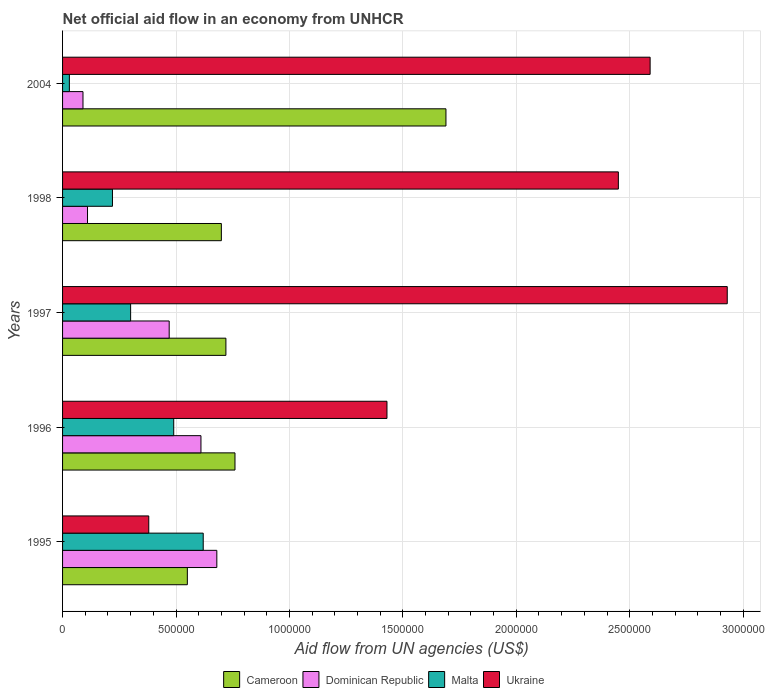How many different coloured bars are there?
Ensure brevity in your answer.  4. How many groups of bars are there?
Give a very brief answer. 5. Are the number of bars on each tick of the Y-axis equal?
Ensure brevity in your answer.  Yes. What is the net official aid flow in Malta in 1998?
Your answer should be very brief. 2.20e+05. Across all years, what is the maximum net official aid flow in Cameroon?
Give a very brief answer. 1.69e+06. In which year was the net official aid flow in Malta maximum?
Offer a terse response. 1995. In which year was the net official aid flow in Ukraine minimum?
Give a very brief answer. 1995. What is the total net official aid flow in Malta in the graph?
Give a very brief answer. 1.66e+06. What is the difference between the net official aid flow in Ukraine in 2004 and the net official aid flow in Dominican Republic in 1997?
Offer a terse response. 2.12e+06. What is the average net official aid flow in Dominican Republic per year?
Give a very brief answer. 3.92e+05. In the year 1996, what is the difference between the net official aid flow in Malta and net official aid flow in Ukraine?
Give a very brief answer. -9.40e+05. In how many years, is the net official aid flow in Cameroon greater than 2100000 US$?
Offer a terse response. 0. What is the ratio of the net official aid flow in Cameroon in 1995 to that in 1998?
Keep it short and to the point. 0.79. Is the net official aid flow in Malta in 1997 less than that in 1998?
Ensure brevity in your answer.  No. What is the difference between the highest and the lowest net official aid flow in Dominican Republic?
Give a very brief answer. 5.90e+05. In how many years, is the net official aid flow in Dominican Republic greater than the average net official aid flow in Dominican Republic taken over all years?
Your answer should be very brief. 3. Is the sum of the net official aid flow in Ukraine in 1995 and 1996 greater than the maximum net official aid flow in Malta across all years?
Keep it short and to the point. Yes. Is it the case that in every year, the sum of the net official aid flow in Malta and net official aid flow in Cameroon is greater than the sum of net official aid flow in Dominican Republic and net official aid flow in Ukraine?
Your response must be concise. No. What does the 2nd bar from the top in 1995 represents?
Offer a very short reply. Malta. What does the 2nd bar from the bottom in 1997 represents?
Offer a terse response. Dominican Republic. Is it the case that in every year, the sum of the net official aid flow in Malta and net official aid flow in Dominican Republic is greater than the net official aid flow in Cameroon?
Provide a short and direct response. No. Are all the bars in the graph horizontal?
Ensure brevity in your answer.  Yes. How many years are there in the graph?
Your answer should be compact. 5. Are the values on the major ticks of X-axis written in scientific E-notation?
Your answer should be very brief. No. Does the graph contain grids?
Provide a short and direct response. Yes. Where does the legend appear in the graph?
Provide a succinct answer. Bottom center. What is the title of the graph?
Ensure brevity in your answer.  Net official aid flow in an economy from UNHCR. What is the label or title of the X-axis?
Your response must be concise. Aid flow from UN agencies (US$). What is the Aid flow from UN agencies (US$) in Cameroon in 1995?
Keep it short and to the point. 5.50e+05. What is the Aid flow from UN agencies (US$) in Dominican Republic in 1995?
Give a very brief answer. 6.80e+05. What is the Aid flow from UN agencies (US$) in Malta in 1995?
Your answer should be compact. 6.20e+05. What is the Aid flow from UN agencies (US$) of Ukraine in 1995?
Give a very brief answer. 3.80e+05. What is the Aid flow from UN agencies (US$) of Cameroon in 1996?
Give a very brief answer. 7.60e+05. What is the Aid flow from UN agencies (US$) in Dominican Republic in 1996?
Offer a very short reply. 6.10e+05. What is the Aid flow from UN agencies (US$) in Ukraine in 1996?
Make the answer very short. 1.43e+06. What is the Aid flow from UN agencies (US$) of Cameroon in 1997?
Provide a succinct answer. 7.20e+05. What is the Aid flow from UN agencies (US$) in Dominican Republic in 1997?
Offer a very short reply. 4.70e+05. What is the Aid flow from UN agencies (US$) in Malta in 1997?
Make the answer very short. 3.00e+05. What is the Aid flow from UN agencies (US$) in Ukraine in 1997?
Your answer should be very brief. 2.93e+06. What is the Aid flow from UN agencies (US$) of Ukraine in 1998?
Offer a very short reply. 2.45e+06. What is the Aid flow from UN agencies (US$) of Cameroon in 2004?
Provide a short and direct response. 1.69e+06. What is the Aid flow from UN agencies (US$) in Dominican Republic in 2004?
Keep it short and to the point. 9.00e+04. What is the Aid flow from UN agencies (US$) in Ukraine in 2004?
Offer a terse response. 2.59e+06. Across all years, what is the maximum Aid flow from UN agencies (US$) of Cameroon?
Your response must be concise. 1.69e+06. Across all years, what is the maximum Aid flow from UN agencies (US$) of Dominican Republic?
Offer a terse response. 6.80e+05. Across all years, what is the maximum Aid flow from UN agencies (US$) in Malta?
Your response must be concise. 6.20e+05. Across all years, what is the maximum Aid flow from UN agencies (US$) in Ukraine?
Provide a succinct answer. 2.93e+06. Across all years, what is the minimum Aid flow from UN agencies (US$) of Cameroon?
Provide a short and direct response. 5.50e+05. Across all years, what is the minimum Aid flow from UN agencies (US$) of Malta?
Your response must be concise. 3.00e+04. What is the total Aid flow from UN agencies (US$) in Cameroon in the graph?
Provide a short and direct response. 4.42e+06. What is the total Aid flow from UN agencies (US$) in Dominican Republic in the graph?
Provide a succinct answer. 1.96e+06. What is the total Aid flow from UN agencies (US$) in Malta in the graph?
Your response must be concise. 1.66e+06. What is the total Aid flow from UN agencies (US$) in Ukraine in the graph?
Offer a very short reply. 9.78e+06. What is the difference between the Aid flow from UN agencies (US$) in Cameroon in 1995 and that in 1996?
Offer a very short reply. -2.10e+05. What is the difference between the Aid flow from UN agencies (US$) of Ukraine in 1995 and that in 1996?
Your response must be concise. -1.05e+06. What is the difference between the Aid flow from UN agencies (US$) in Ukraine in 1995 and that in 1997?
Provide a succinct answer. -2.55e+06. What is the difference between the Aid flow from UN agencies (US$) in Cameroon in 1995 and that in 1998?
Make the answer very short. -1.50e+05. What is the difference between the Aid flow from UN agencies (US$) of Dominican Republic in 1995 and that in 1998?
Your answer should be very brief. 5.70e+05. What is the difference between the Aid flow from UN agencies (US$) of Ukraine in 1995 and that in 1998?
Provide a short and direct response. -2.07e+06. What is the difference between the Aid flow from UN agencies (US$) of Cameroon in 1995 and that in 2004?
Keep it short and to the point. -1.14e+06. What is the difference between the Aid flow from UN agencies (US$) of Dominican Republic in 1995 and that in 2004?
Offer a terse response. 5.90e+05. What is the difference between the Aid flow from UN agencies (US$) of Malta in 1995 and that in 2004?
Ensure brevity in your answer.  5.90e+05. What is the difference between the Aid flow from UN agencies (US$) of Ukraine in 1995 and that in 2004?
Your answer should be compact. -2.21e+06. What is the difference between the Aid flow from UN agencies (US$) of Dominican Republic in 1996 and that in 1997?
Provide a succinct answer. 1.40e+05. What is the difference between the Aid flow from UN agencies (US$) in Ukraine in 1996 and that in 1997?
Offer a very short reply. -1.50e+06. What is the difference between the Aid flow from UN agencies (US$) of Malta in 1996 and that in 1998?
Keep it short and to the point. 2.70e+05. What is the difference between the Aid flow from UN agencies (US$) of Ukraine in 1996 and that in 1998?
Give a very brief answer. -1.02e+06. What is the difference between the Aid flow from UN agencies (US$) in Cameroon in 1996 and that in 2004?
Keep it short and to the point. -9.30e+05. What is the difference between the Aid flow from UN agencies (US$) in Dominican Republic in 1996 and that in 2004?
Offer a terse response. 5.20e+05. What is the difference between the Aid flow from UN agencies (US$) of Malta in 1996 and that in 2004?
Provide a succinct answer. 4.60e+05. What is the difference between the Aid flow from UN agencies (US$) in Ukraine in 1996 and that in 2004?
Ensure brevity in your answer.  -1.16e+06. What is the difference between the Aid flow from UN agencies (US$) in Cameroon in 1997 and that in 1998?
Give a very brief answer. 2.00e+04. What is the difference between the Aid flow from UN agencies (US$) in Ukraine in 1997 and that in 1998?
Give a very brief answer. 4.80e+05. What is the difference between the Aid flow from UN agencies (US$) of Cameroon in 1997 and that in 2004?
Ensure brevity in your answer.  -9.70e+05. What is the difference between the Aid flow from UN agencies (US$) in Malta in 1997 and that in 2004?
Ensure brevity in your answer.  2.70e+05. What is the difference between the Aid flow from UN agencies (US$) of Ukraine in 1997 and that in 2004?
Your response must be concise. 3.40e+05. What is the difference between the Aid flow from UN agencies (US$) of Cameroon in 1998 and that in 2004?
Your answer should be very brief. -9.90e+05. What is the difference between the Aid flow from UN agencies (US$) of Malta in 1998 and that in 2004?
Your answer should be compact. 1.90e+05. What is the difference between the Aid flow from UN agencies (US$) of Ukraine in 1998 and that in 2004?
Your answer should be very brief. -1.40e+05. What is the difference between the Aid flow from UN agencies (US$) in Cameroon in 1995 and the Aid flow from UN agencies (US$) in Ukraine in 1996?
Your answer should be compact. -8.80e+05. What is the difference between the Aid flow from UN agencies (US$) in Dominican Republic in 1995 and the Aid flow from UN agencies (US$) in Malta in 1996?
Give a very brief answer. 1.90e+05. What is the difference between the Aid flow from UN agencies (US$) in Dominican Republic in 1995 and the Aid flow from UN agencies (US$) in Ukraine in 1996?
Offer a terse response. -7.50e+05. What is the difference between the Aid flow from UN agencies (US$) of Malta in 1995 and the Aid flow from UN agencies (US$) of Ukraine in 1996?
Offer a terse response. -8.10e+05. What is the difference between the Aid flow from UN agencies (US$) of Cameroon in 1995 and the Aid flow from UN agencies (US$) of Dominican Republic in 1997?
Your response must be concise. 8.00e+04. What is the difference between the Aid flow from UN agencies (US$) in Cameroon in 1995 and the Aid flow from UN agencies (US$) in Ukraine in 1997?
Provide a succinct answer. -2.38e+06. What is the difference between the Aid flow from UN agencies (US$) in Dominican Republic in 1995 and the Aid flow from UN agencies (US$) in Malta in 1997?
Ensure brevity in your answer.  3.80e+05. What is the difference between the Aid flow from UN agencies (US$) in Dominican Republic in 1995 and the Aid flow from UN agencies (US$) in Ukraine in 1997?
Provide a succinct answer. -2.25e+06. What is the difference between the Aid flow from UN agencies (US$) of Malta in 1995 and the Aid flow from UN agencies (US$) of Ukraine in 1997?
Give a very brief answer. -2.31e+06. What is the difference between the Aid flow from UN agencies (US$) of Cameroon in 1995 and the Aid flow from UN agencies (US$) of Dominican Republic in 1998?
Your response must be concise. 4.40e+05. What is the difference between the Aid flow from UN agencies (US$) of Cameroon in 1995 and the Aid flow from UN agencies (US$) of Malta in 1998?
Give a very brief answer. 3.30e+05. What is the difference between the Aid flow from UN agencies (US$) of Cameroon in 1995 and the Aid flow from UN agencies (US$) of Ukraine in 1998?
Provide a succinct answer. -1.90e+06. What is the difference between the Aid flow from UN agencies (US$) of Dominican Republic in 1995 and the Aid flow from UN agencies (US$) of Ukraine in 1998?
Provide a short and direct response. -1.77e+06. What is the difference between the Aid flow from UN agencies (US$) in Malta in 1995 and the Aid flow from UN agencies (US$) in Ukraine in 1998?
Your answer should be compact. -1.83e+06. What is the difference between the Aid flow from UN agencies (US$) of Cameroon in 1995 and the Aid flow from UN agencies (US$) of Dominican Republic in 2004?
Keep it short and to the point. 4.60e+05. What is the difference between the Aid flow from UN agencies (US$) of Cameroon in 1995 and the Aid flow from UN agencies (US$) of Malta in 2004?
Your answer should be compact. 5.20e+05. What is the difference between the Aid flow from UN agencies (US$) in Cameroon in 1995 and the Aid flow from UN agencies (US$) in Ukraine in 2004?
Provide a short and direct response. -2.04e+06. What is the difference between the Aid flow from UN agencies (US$) of Dominican Republic in 1995 and the Aid flow from UN agencies (US$) of Malta in 2004?
Provide a short and direct response. 6.50e+05. What is the difference between the Aid flow from UN agencies (US$) of Dominican Republic in 1995 and the Aid flow from UN agencies (US$) of Ukraine in 2004?
Provide a short and direct response. -1.91e+06. What is the difference between the Aid flow from UN agencies (US$) of Malta in 1995 and the Aid flow from UN agencies (US$) of Ukraine in 2004?
Make the answer very short. -1.97e+06. What is the difference between the Aid flow from UN agencies (US$) in Cameroon in 1996 and the Aid flow from UN agencies (US$) in Malta in 1997?
Your answer should be compact. 4.60e+05. What is the difference between the Aid flow from UN agencies (US$) of Cameroon in 1996 and the Aid flow from UN agencies (US$) of Ukraine in 1997?
Your answer should be very brief. -2.17e+06. What is the difference between the Aid flow from UN agencies (US$) of Dominican Republic in 1996 and the Aid flow from UN agencies (US$) of Ukraine in 1997?
Ensure brevity in your answer.  -2.32e+06. What is the difference between the Aid flow from UN agencies (US$) in Malta in 1996 and the Aid flow from UN agencies (US$) in Ukraine in 1997?
Your response must be concise. -2.44e+06. What is the difference between the Aid flow from UN agencies (US$) in Cameroon in 1996 and the Aid flow from UN agencies (US$) in Dominican Republic in 1998?
Give a very brief answer. 6.50e+05. What is the difference between the Aid flow from UN agencies (US$) in Cameroon in 1996 and the Aid flow from UN agencies (US$) in Malta in 1998?
Your answer should be compact. 5.40e+05. What is the difference between the Aid flow from UN agencies (US$) in Cameroon in 1996 and the Aid flow from UN agencies (US$) in Ukraine in 1998?
Offer a very short reply. -1.69e+06. What is the difference between the Aid flow from UN agencies (US$) of Dominican Republic in 1996 and the Aid flow from UN agencies (US$) of Malta in 1998?
Provide a succinct answer. 3.90e+05. What is the difference between the Aid flow from UN agencies (US$) of Dominican Republic in 1996 and the Aid flow from UN agencies (US$) of Ukraine in 1998?
Your answer should be compact. -1.84e+06. What is the difference between the Aid flow from UN agencies (US$) in Malta in 1996 and the Aid flow from UN agencies (US$) in Ukraine in 1998?
Offer a very short reply. -1.96e+06. What is the difference between the Aid flow from UN agencies (US$) in Cameroon in 1996 and the Aid flow from UN agencies (US$) in Dominican Republic in 2004?
Your response must be concise. 6.70e+05. What is the difference between the Aid flow from UN agencies (US$) of Cameroon in 1996 and the Aid flow from UN agencies (US$) of Malta in 2004?
Provide a short and direct response. 7.30e+05. What is the difference between the Aid flow from UN agencies (US$) in Cameroon in 1996 and the Aid flow from UN agencies (US$) in Ukraine in 2004?
Make the answer very short. -1.83e+06. What is the difference between the Aid flow from UN agencies (US$) of Dominican Republic in 1996 and the Aid flow from UN agencies (US$) of Malta in 2004?
Offer a terse response. 5.80e+05. What is the difference between the Aid flow from UN agencies (US$) of Dominican Republic in 1996 and the Aid flow from UN agencies (US$) of Ukraine in 2004?
Provide a succinct answer. -1.98e+06. What is the difference between the Aid flow from UN agencies (US$) in Malta in 1996 and the Aid flow from UN agencies (US$) in Ukraine in 2004?
Offer a very short reply. -2.10e+06. What is the difference between the Aid flow from UN agencies (US$) in Cameroon in 1997 and the Aid flow from UN agencies (US$) in Malta in 1998?
Offer a very short reply. 5.00e+05. What is the difference between the Aid flow from UN agencies (US$) of Cameroon in 1997 and the Aid flow from UN agencies (US$) of Ukraine in 1998?
Provide a succinct answer. -1.73e+06. What is the difference between the Aid flow from UN agencies (US$) of Dominican Republic in 1997 and the Aid flow from UN agencies (US$) of Malta in 1998?
Provide a succinct answer. 2.50e+05. What is the difference between the Aid flow from UN agencies (US$) of Dominican Republic in 1997 and the Aid flow from UN agencies (US$) of Ukraine in 1998?
Your response must be concise. -1.98e+06. What is the difference between the Aid flow from UN agencies (US$) of Malta in 1997 and the Aid flow from UN agencies (US$) of Ukraine in 1998?
Offer a terse response. -2.15e+06. What is the difference between the Aid flow from UN agencies (US$) in Cameroon in 1997 and the Aid flow from UN agencies (US$) in Dominican Republic in 2004?
Your answer should be very brief. 6.30e+05. What is the difference between the Aid flow from UN agencies (US$) of Cameroon in 1997 and the Aid flow from UN agencies (US$) of Malta in 2004?
Ensure brevity in your answer.  6.90e+05. What is the difference between the Aid flow from UN agencies (US$) of Cameroon in 1997 and the Aid flow from UN agencies (US$) of Ukraine in 2004?
Provide a short and direct response. -1.87e+06. What is the difference between the Aid flow from UN agencies (US$) in Dominican Republic in 1997 and the Aid flow from UN agencies (US$) in Malta in 2004?
Provide a short and direct response. 4.40e+05. What is the difference between the Aid flow from UN agencies (US$) in Dominican Republic in 1997 and the Aid flow from UN agencies (US$) in Ukraine in 2004?
Offer a very short reply. -2.12e+06. What is the difference between the Aid flow from UN agencies (US$) in Malta in 1997 and the Aid flow from UN agencies (US$) in Ukraine in 2004?
Provide a succinct answer. -2.29e+06. What is the difference between the Aid flow from UN agencies (US$) of Cameroon in 1998 and the Aid flow from UN agencies (US$) of Malta in 2004?
Offer a very short reply. 6.70e+05. What is the difference between the Aid flow from UN agencies (US$) in Cameroon in 1998 and the Aid flow from UN agencies (US$) in Ukraine in 2004?
Provide a short and direct response. -1.89e+06. What is the difference between the Aid flow from UN agencies (US$) in Dominican Republic in 1998 and the Aid flow from UN agencies (US$) in Malta in 2004?
Make the answer very short. 8.00e+04. What is the difference between the Aid flow from UN agencies (US$) of Dominican Republic in 1998 and the Aid flow from UN agencies (US$) of Ukraine in 2004?
Your answer should be compact. -2.48e+06. What is the difference between the Aid flow from UN agencies (US$) of Malta in 1998 and the Aid flow from UN agencies (US$) of Ukraine in 2004?
Make the answer very short. -2.37e+06. What is the average Aid flow from UN agencies (US$) of Cameroon per year?
Provide a succinct answer. 8.84e+05. What is the average Aid flow from UN agencies (US$) in Dominican Republic per year?
Give a very brief answer. 3.92e+05. What is the average Aid flow from UN agencies (US$) of Malta per year?
Give a very brief answer. 3.32e+05. What is the average Aid flow from UN agencies (US$) in Ukraine per year?
Your answer should be very brief. 1.96e+06. In the year 1995, what is the difference between the Aid flow from UN agencies (US$) of Cameroon and Aid flow from UN agencies (US$) of Dominican Republic?
Give a very brief answer. -1.30e+05. In the year 1995, what is the difference between the Aid flow from UN agencies (US$) in Dominican Republic and Aid flow from UN agencies (US$) in Malta?
Your answer should be compact. 6.00e+04. In the year 1995, what is the difference between the Aid flow from UN agencies (US$) in Malta and Aid flow from UN agencies (US$) in Ukraine?
Your response must be concise. 2.40e+05. In the year 1996, what is the difference between the Aid flow from UN agencies (US$) of Cameroon and Aid flow from UN agencies (US$) of Dominican Republic?
Provide a succinct answer. 1.50e+05. In the year 1996, what is the difference between the Aid flow from UN agencies (US$) in Cameroon and Aid flow from UN agencies (US$) in Ukraine?
Offer a terse response. -6.70e+05. In the year 1996, what is the difference between the Aid flow from UN agencies (US$) of Dominican Republic and Aid flow from UN agencies (US$) of Malta?
Offer a terse response. 1.20e+05. In the year 1996, what is the difference between the Aid flow from UN agencies (US$) of Dominican Republic and Aid flow from UN agencies (US$) of Ukraine?
Ensure brevity in your answer.  -8.20e+05. In the year 1996, what is the difference between the Aid flow from UN agencies (US$) in Malta and Aid flow from UN agencies (US$) in Ukraine?
Offer a terse response. -9.40e+05. In the year 1997, what is the difference between the Aid flow from UN agencies (US$) of Cameroon and Aid flow from UN agencies (US$) of Malta?
Provide a succinct answer. 4.20e+05. In the year 1997, what is the difference between the Aid flow from UN agencies (US$) in Cameroon and Aid flow from UN agencies (US$) in Ukraine?
Ensure brevity in your answer.  -2.21e+06. In the year 1997, what is the difference between the Aid flow from UN agencies (US$) in Dominican Republic and Aid flow from UN agencies (US$) in Malta?
Keep it short and to the point. 1.70e+05. In the year 1997, what is the difference between the Aid flow from UN agencies (US$) of Dominican Republic and Aid flow from UN agencies (US$) of Ukraine?
Offer a very short reply. -2.46e+06. In the year 1997, what is the difference between the Aid flow from UN agencies (US$) in Malta and Aid flow from UN agencies (US$) in Ukraine?
Provide a short and direct response. -2.63e+06. In the year 1998, what is the difference between the Aid flow from UN agencies (US$) in Cameroon and Aid flow from UN agencies (US$) in Dominican Republic?
Provide a short and direct response. 5.90e+05. In the year 1998, what is the difference between the Aid flow from UN agencies (US$) in Cameroon and Aid flow from UN agencies (US$) in Ukraine?
Provide a short and direct response. -1.75e+06. In the year 1998, what is the difference between the Aid flow from UN agencies (US$) of Dominican Republic and Aid flow from UN agencies (US$) of Malta?
Provide a succinct answer. -1.10e+05. In the year 1998, what is the difference between the Aid flow from UN agencies (US$) in Dominican Republic and Aid flow from UN agencies (US$) in Ukraine?
Provide a succinct answer. -2.34e+06. In the year 1998, what is the difference between the Aid flow from UN agencies (US$) of Malta and Aid flow from UN agencies (US$) of Ukraine?
Provide a succinct answer. -2.23e+06. In the year 2004, what is the difference between the Aid flow from UN agencies (US$) of Cameroon and Aid flow from UN agencies (US$) of Dominican Republic?
Give a very brief answer. 1.60e+06. In the year 2004, what is the difference between the Aid flow from UN agencies (US$) in Cameroon and Aid flow from UN agencies (US$) in Malta?
Your response must be concise. 1.66e+06. In the year 2004, what is the difference between the Aid flow from UN agencies (US$) of Cameroon and Aid flow from UN agencies (US$) of Ukraine?
Make the answer very short. -9.00e+05. In the year 2004, what is the difference between the Aid flow from UN agencies (US$) in Dominican Republic and Aid flow from UN agencies (US$) in Ukraine?
Ensure brevity in your answer.  -2.50e+06. In the year 2004, what is the difference between the Aid flow from UN agencies (US$) in Malta and Aid flow from UN agencies (US$) in Ukraine?
Your answer should be compact. -2.56e+06. What is the ratio of the Aid flow from UN agencies (US$) of Cameroon in 1995 to that in 1996?
Your answer should be very brief. 0.72. What is the ratio of the Aid flow from UN agencies (US$) in Dominican Republic in 1995 to that in 1996?
Your answer should be compact. 1.11. What is the ratio of the Aid flow from UN agencies (US$) of Malta in 1995 to that in 1996?
Ensure brevity in your answer.  1.27. What is the ratio of the Aid flow from UN agencies (US$) of Ukraine in 1995 to that in 1996?
Offer a very short reply. 0.27. What is the ratio of the Aid flow from UN agencies (US$) of Cameroon in 1995 to that in 1997?
Your answer should be very brief. 0.76. What is the ratio of the Aid flow from UN agencies (US$) of Dominican Republic in 1995 to that in 1997?
Your answer should be compact. 1.45. What is the ratio of the Aid flow from UN agencies (US$) in Malta in 1995 to that in 1997?
Your response must be concise. 2.07. What is the ratio of the Aid flow from UN agencies (US$) in Ukraine in 1995 to that in 1997?
Your answer should be very brief. 0.13. What is the ratio of the Aid flow from UN agencies (US$) of Cameroon in 1995 to that in 1998?
Make the answer very short. 0.79. What is the ratio of the Aid flow from UN agencies (US$) of Dominican Republic in 1995 to that in 1998?
Make the answer very short. 6.18. What is the ratio of the Aid flow from UN agencies (US$) in Malta in 1995 to that in 1998?
Your answer should be compact. 2.82. What is the ratio of the Aid flow from UN agencies (US$) in Ukraine in 1995 to that in 1998?
Your response must be concise. 0.16. What is the ratio of the Aid flow from UN agencies (US$) in Cameroon in 1995 to that in 2004?
Your response must be concise. 0.33. What is the ratio of the Aid flow from UN agencies (US$) of Dominican Republic in 1995 to that in 2004?
Offer a terse response. 7.56. What is the ratio of the Aid flow from UN agencies (US$) in Malta in 1995 to that in 2004?
Your answer should be very brief. 20.67. What is the ratio of the Aid flow from UN agencies (US$) of Ukraine in 1995 to that in 2004?
Your response must be concise. 0.15. What is the ratio of the Aid flow from UN agencies (US$) of Cameroon in 1996 to that in 1997?
Your answer should be very brief. 1.06. What is the ratio of the Aid flow from UN agencies (US$) in Dominican Republic in 1996 to that in 1997?
Provide a short and direct response. 1.3. What is the ratio of the Aid flow from UN agencies (US$) of Malta in 1996 to that in 1997?
Offer a terse response. 1.63. What is the ratio of the Aid flow from UN agencies (US$) of Ukraine in 1996 to that in 1997?
Provide a succinct answer. 0.49. What is the ratio of the Aid flow from UN agencies (US$) of Cameroon in 1996 to that in 1998?
Your answer should be very brief. 1.09. What is the ratio of the Aid flow from UN agencies (US$) in Dominican Republic in 1996 to that in 1998?
Offer a terse response. 5.55. What is the ratio of the Aid flow from UN agencies (US$) of Malta in 1996 to that in 1998?
Your answer should be very brief. 2.23. What is the ratio of the Aid flow from UN agencies (US$) in Ukraine in 1996 to that in 1998?
Offer a very short reply. 0.58. What is the ratio of the Aid flow from UN agencies (US$) in Cameroon in 1996 to that in 2004?
Your response must be concise. 0.45. What is the ratio of the Aid flow from UN agencies (US$) of Dominican Republic in 1996 to that in 2004?
Offer a terse response. 6.78. What is the ratio of the Aid flow from UN agencies (US$) of Malta in 1996 to that in 2004?
Your answer should be compact. 16.33. What is the ratio of the Aid flow from UN agencies (US$) of Ukraine in 1996 to that in 2004?
Provide a short and direct response. 0.55. What is the ratio of the Aid flow from UN agencies (US$) of Cameroon in 1997 to that in 1998?
Ensure brevity in your answer.  1.03. What is the ratio of the Aid flow from UN agencies (US$) of Dominican Republic in 1997 to that in 1998?
Offer a very short reply. 4.27. What is the ratio of the Aid flow from UN agencies (US$) of Malta in 1997 to that in 1998?
Your answer should be compact. 1.36. What is the ratio of the Aid flow from UN agencies (US$) in Ukraine in 1997 to that in 1998?
Your answer should be compact. 1.2. What is the ratio of the Aid flow from UN agencies (US$) in Cameroon in 1997 to that in 2004?
Your answer should be very brief. 0.43. What is the ratio of the Aid flow from UN agencies (US$) of Dominican Republic in 1997 to that in 2004?
Keep it short and to the point. 5.22. What is the ratio of the Aid flow from UN agencies (US$) in Ukraine in 1997 to that in 2004?
Keep it short and to the point. 1.13. What is the ratio of the Aid flow from UN agencies (US$) of Cameroon in 1998 to that in 2004?
Your answer should be very brief. 0.41. What is the ratio of the Aid flow from UN agencies (US$) of Dominican Republic in 1998 to that in 2004?
Provide a short and direct response. 1.22. What is the ratio of the Aid flow from UN agencies (US$) of Malta in 1998 to that in 2004?
Make the answer very short. 7.33. What is the ratio of the Aid flow from UN agencies (US$) in Ukraine in 1998 to that in 2004?
Your answer should be very brief. 0.95. What is the difference between the highest and the second highest Aid flow from UN agencies (US$) of Cameroon?
Offer a terse response. 9.30e+05. What is the difference between the highest and the second highest Aid flow from UN agencies (US$) in Dominican Republic?
Your response must be concise. 7.00e+04. What is the difference between the highest and the second highest Aid flow from UN agencies (US$) of Malta?
Ensure brevity in your answer.  1.30e+05. What is the difference between the highest and the second highest Aid flow from UN agencies (US$) in Ukraine?
Ensure brevity in your answer.  3.40e+05. What is the difference between the highest and the lowest Aid flow from UN agencies (US$) in Cameroon?
Your answer should be compact. 1.14e+06. What is the difference between the highest and the lowest Aid flow from UN agencies (US$) in Dominican Republic?
Your answer should be very brief. 5.90e+05. What is the difference between the highest and the lowest Aid flow from UN agencies (US$) in Malta?
Make the answer very short. 5.90e+05. What is the difference between the highest and the lowest Aid flow from UN agencies (US$) of Ukraine?
Offer a very short reply. 2.55e+06. 